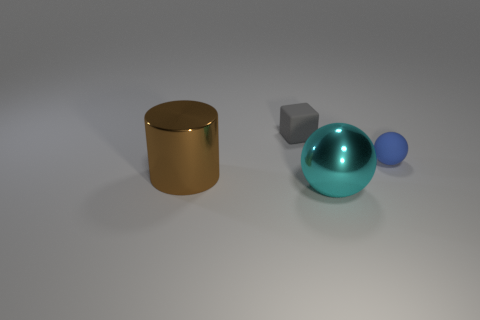Is the ball that is on the left side of the blue object made of the same material as the small blue thing on the right side of the tiny gray cube?
Provide a succinct answer. No. Are there any cyan things that have the same size as the matte block?
Make the answer very short. No. There is a shiny object that is left of the metallic object that is in front of the brown metallic cylinder; what is its size?
Ensure brevity in your answer.  Large. What number of objects have the same color as the cube?
Keep it short and to the point. 0. The big metallic thing that is left of the metallic thing that is in front of the large brown metallic object is what shape?
Your answer should be very brief. Cylinder. What number of large cyan objects have the same material as the large brown thing?
Keep it short and to the point. 1. What is the sphere left of the blue sphere made of?
Give a very brief answer. Metal. What shape is the small thing that is behind the rubber thing that is on the right side of the cyan sphere that is in front of the brown cylinder?
Keep it short and to the point. Cube. Is the color of the small rubber thing on the right side of the gray rubber thing the same as the tiny thing that is left of the big cyan thing?
Your answer should be compact. No. Is the number of matte spheres to the left of the gray rubber cube less than the number of things in front of the small ball?
Ensure brevity in your answer.  Yes. 